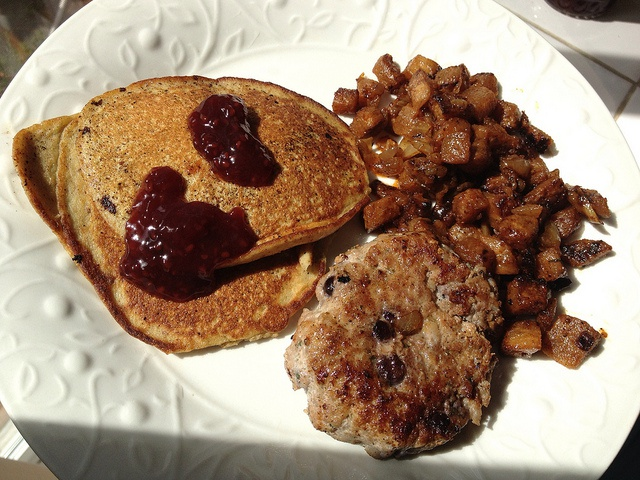Describe the objects in this image and their specific colors. I can see a sandwich in black, brown, maroon, and tan tones in this image. 